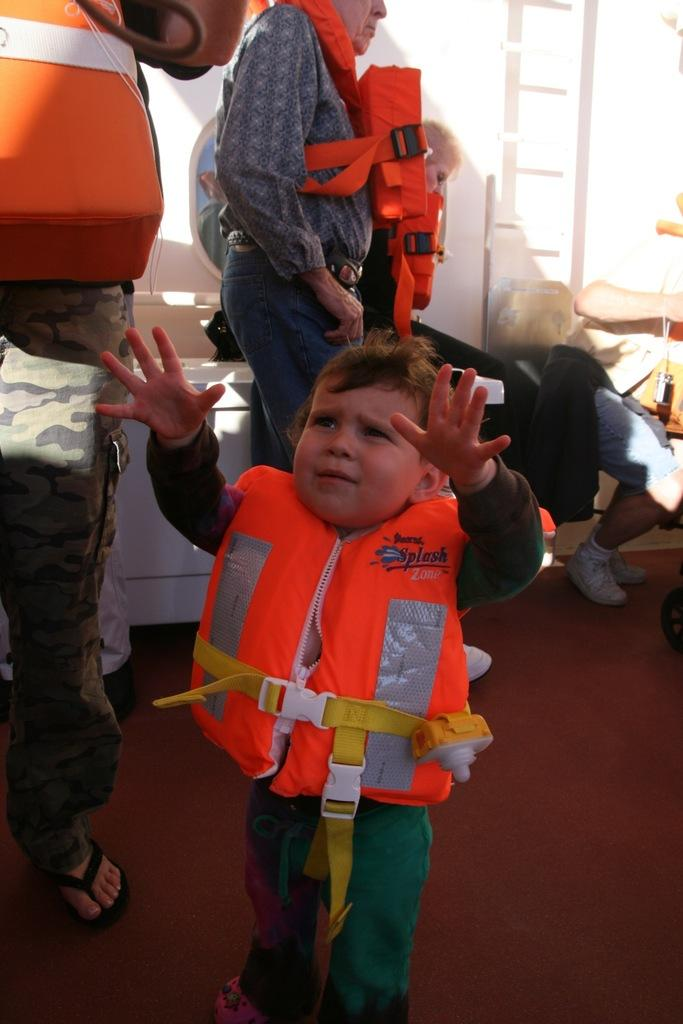Who or what is present in the image? There are people in the image. What are some of the people wearing? Some people are wearing life jackets. Are there any other types of jackets visible in the image? Yes, there are other jackets visible in the image. What can be seen in the background of the image? There is a wall in the image. What color is the kitty sitting on the carriage in the image? There is no kitty or carriage present in the image. What type of gold ornament is hanging from the wall in the image? There is no gold ornament visible in the image. 